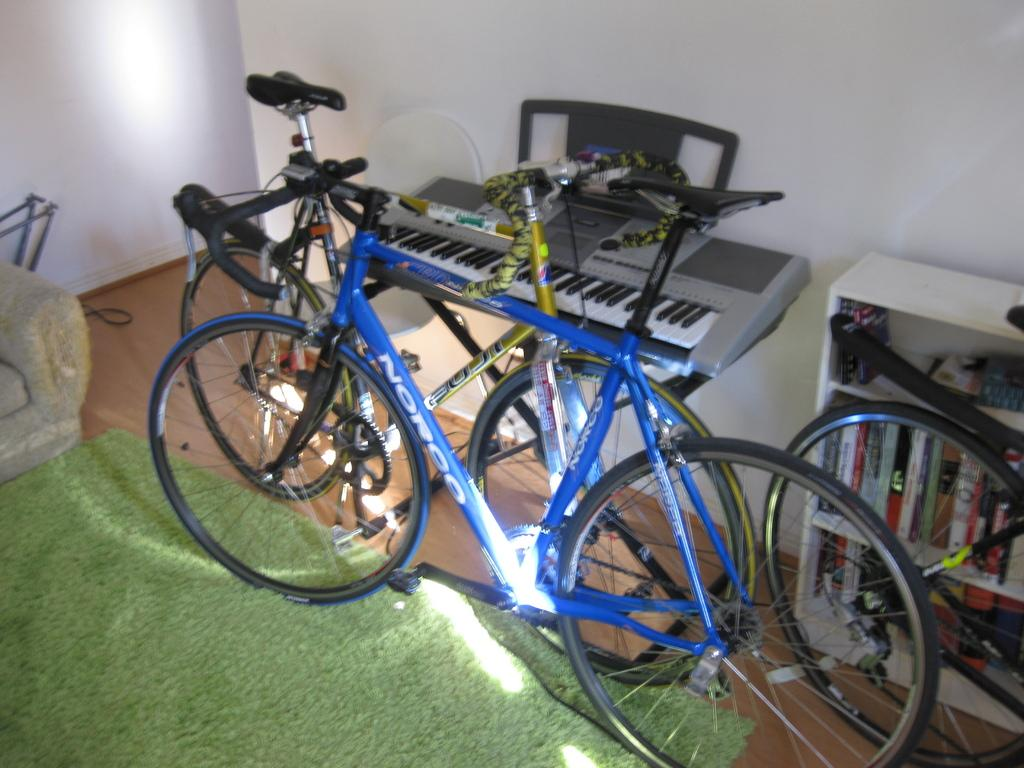What type of vehicles are in the image? There are bicycles in the image. What musical instrument can be seen in the image? There is a piano in the image. What type of furniture is in the image? There is a chair in the image. What is the color of the shelf in the image? The shelf has a white color in the image. What items are on the shelf in the image? The shelf has books and other objects in the image. What type of flooring is in the image? There is a carpet on the floor in the image. Can you tell me how many hens are sitting on the piano in the image? There are no hens present in the image; it features bicycles, a piano, a chair, a white shelf with books and other objects, and a carpet on the floor. What type of protest is happening in the image? There is no protest depicted in the image; it focuses on bicycles, a piano, a chair, a white shelf with books and other objects, and a carpet on the floor. 